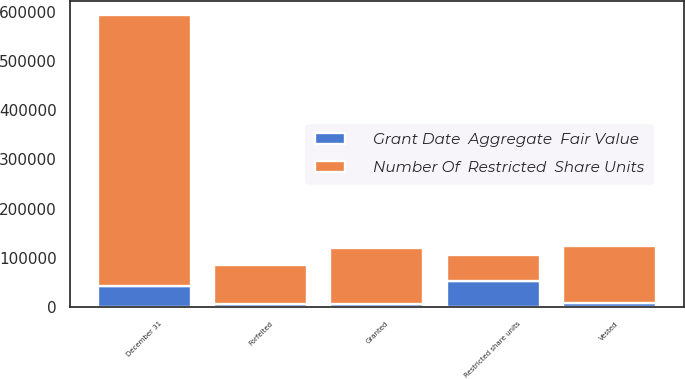<chart> <loc_0><loc_0><loc_500><loc_500><stacked_bar_chart><ecel><fcel>Restricted share units<fcel>Granted<fcel>Vested<fcel>Forfeited<fcel>December 31<nl><fcel>Number Of  Restricted  Share Units<fcel>53132<fcel>112550<fcel>115723<fcel>78685<fcel>548354<nl><fcel>Grant Date  Aggregate  Fair Value<fcel>53132<fcel>7428<fcel>8783<fcel>7465<fcel>44312<nl></chart> 